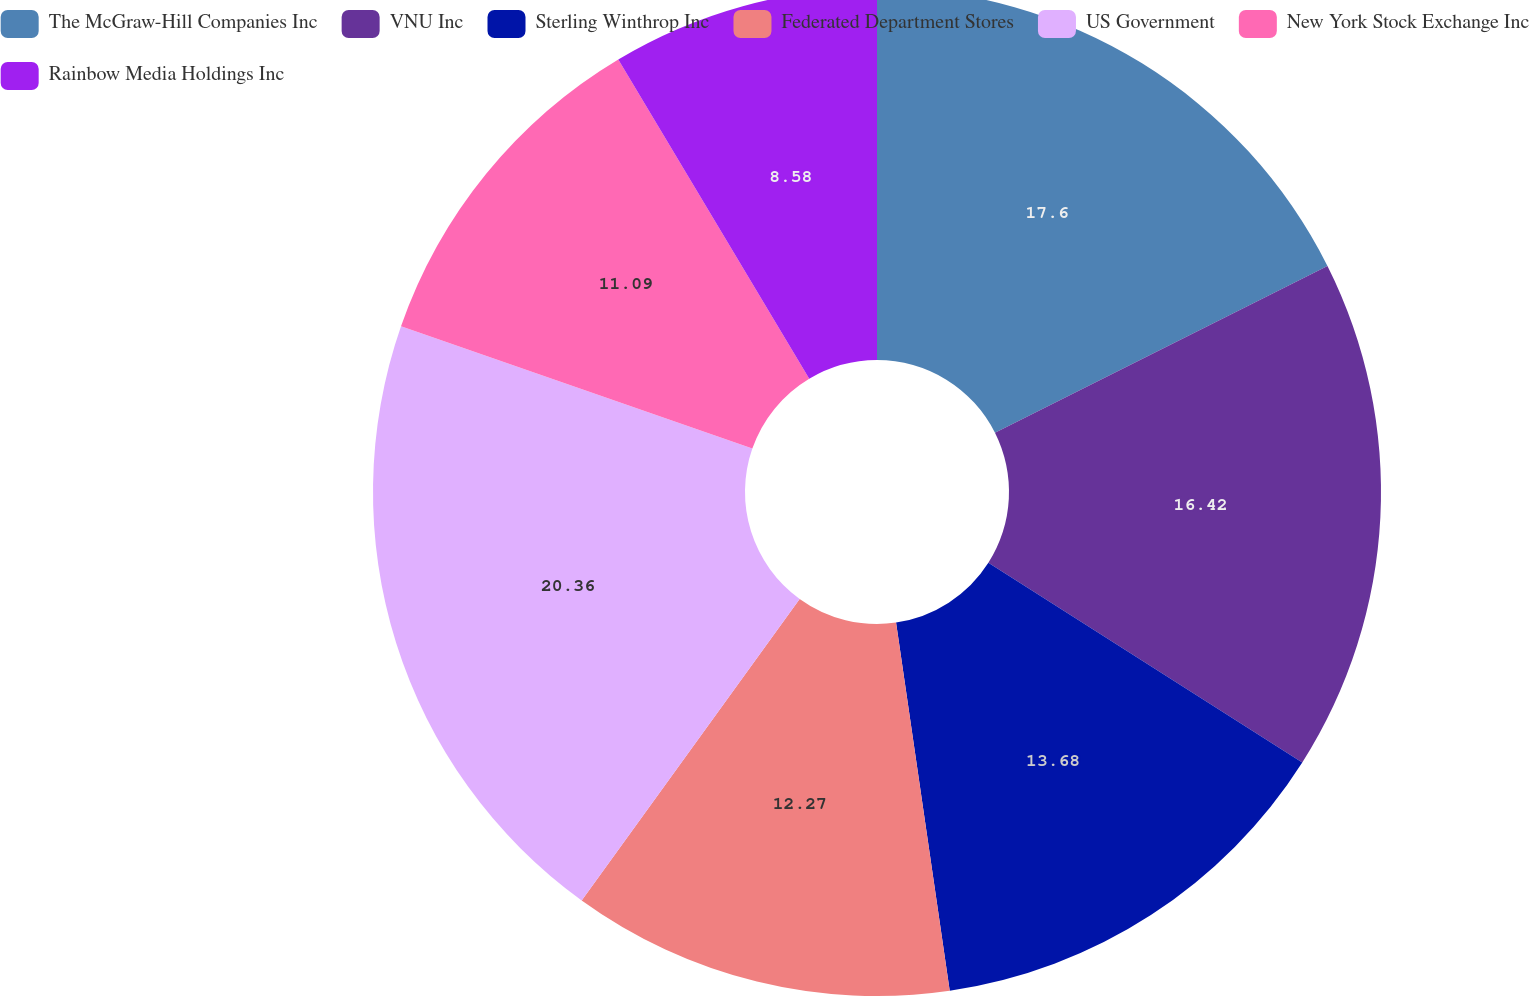Convert chart to OTSL. <chart><loc_0><loc_0><loc_500><loc_500><pie_chart><fcel>The McGraw-Hill Companies Inc<fcel>VNU Inc<fcel>Sterling Winthrop Inc<fcel>Federated Department Stores<fcel>US Government<fcel>New York Stock Exchange Inc<fcel>Rainbow Media Holdings Inc<nl><fcel>17.6%<fcel>16.42%<fcel>13.68%<fcel>12.27%<fcel>20.37%<fcel>11.09%<fcel>8.58%<nl></chart> 